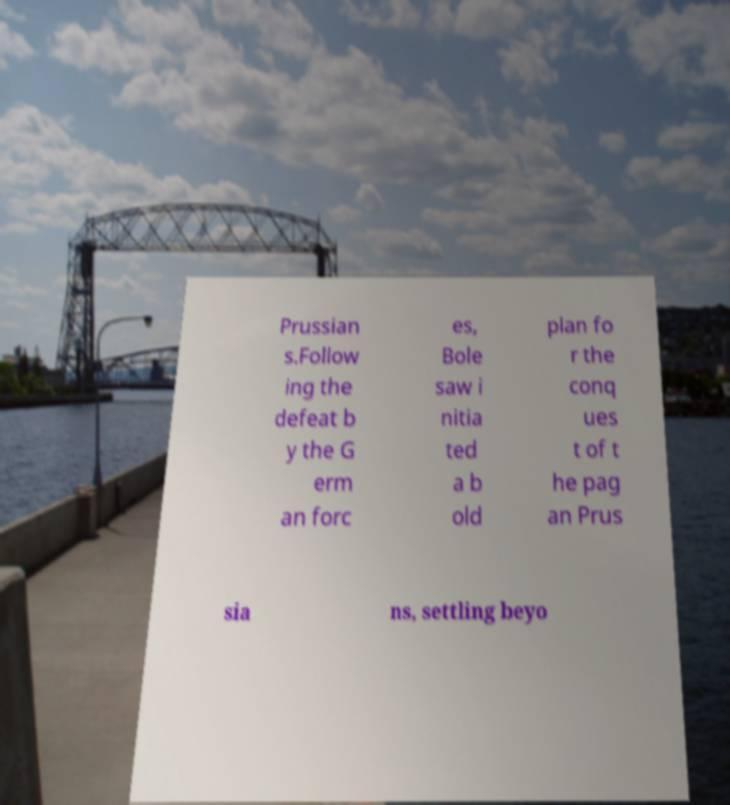Please read and relay the text visible in this image. What does it say? Prussian s.Follow ing the defeat b y the G erm an forc es, Bole saw i nitia ted a b old plan fo r the conq ues t of t he pag an Prus sia ns, settling beyo 